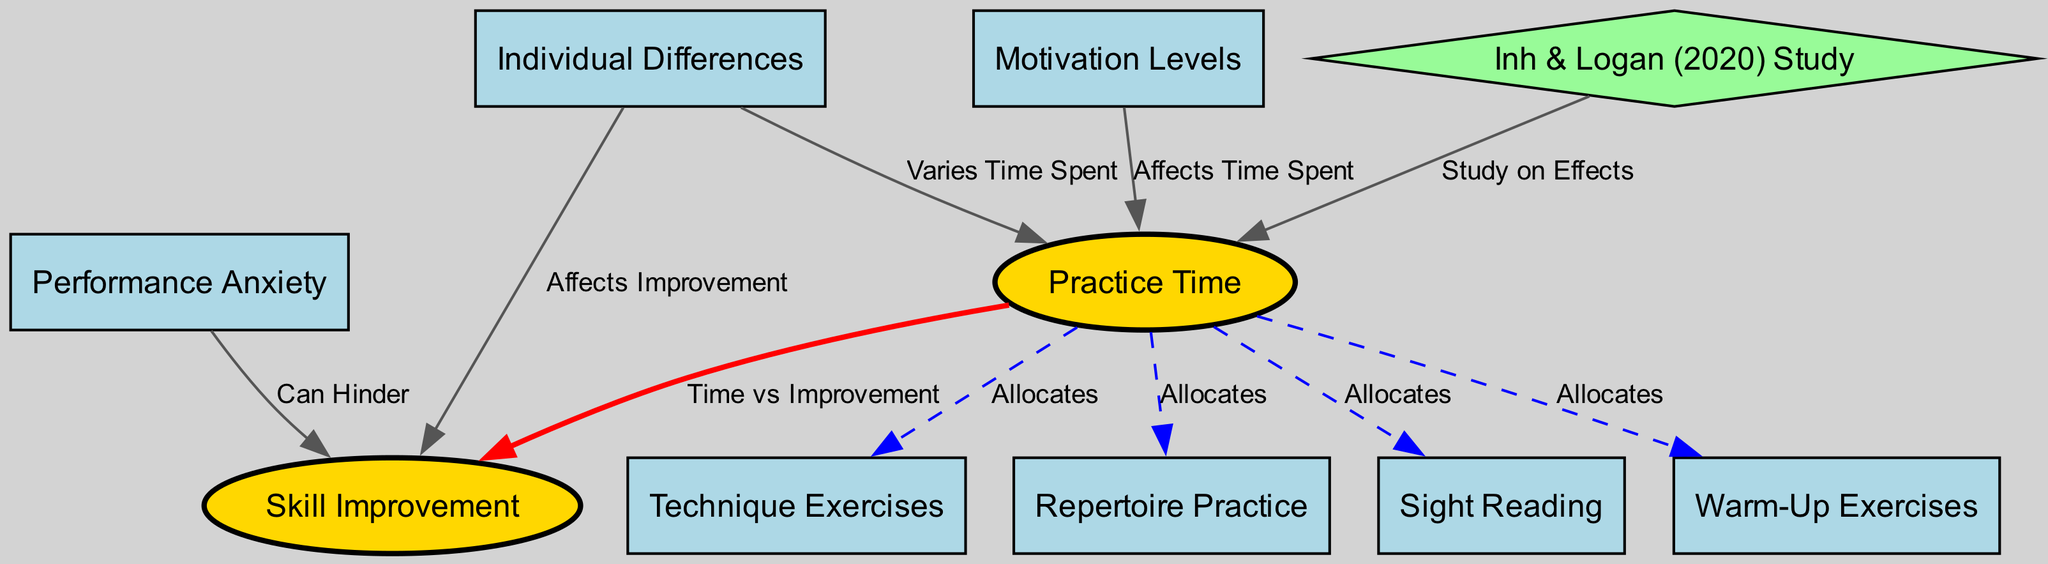What are the two main nodes in this diagram? The two main nodes are identified as "Practice Time" and "Skill Improvement," which are depicted in ellipses. These nodes represent the core concepts being analyzed in the practice routines of classical guitarists.
Answer: Practice Time, Skill Improvement How many edges are connected to the "Practice Time" node? By inspecting the diagram, we can count the edges that extend from "Practice Time." There are five edges leading to "Warm-Up Exercises," "Technique Exercises," "Repertoire Practice," "Sight Reading," and "Skill Improvement."
Answer: Five What does the edge between "Motivation Levels" and "Practice Time" represent? The edge labeled "Affects Time Spent" illustrates the relationship where motivation levels impact the amount of time spent on practice. This denotes that a higher motivation may lead to increased practice time.
Answer: Affects Time Spent Which node can hinder "Skill Improvement"? The edge labeled "Can Hinder" points from "Performance Anxiety" to "Skill Improvement," indicating that performance anxiety can negatively affect a guitarist's ability to improve their skills.
Answer: Performance Anxiety What type of study is linked to "Practice Time"? The node "Inh & Logan (2020) Study" has an edge that connects to "Practice Time," suggesting that this study examined the effects of practice time on skill development in classical guitarists.
Answer: Inh & Logan (2020) Study How do individual differences relate to "Skill Improvement"? The edge between "Inter-Personal Differences" and "Skill Improvement" labeled "Affects Improvement" shows that variation in individual characteristics influences the degree of skill improvement. This means personal traits can change how effectively a guitarist enhances their skills.
Answer: Affects Improvement What is the relationship between "Practice Time" and "Skill Improvement"? The edge marked "Time vs Improvement" indicates a direct connection where the amount of practice time is linked to the level of skill improvement, suggesting that more practice generally leads to better skills.
Answer: Time vs Improvement What is the shape of the node representing the study on effects? The node for "Inh & Logan (2020) Study" is depicted as a diamond, differentiating it from the other nodes that are mostly rectangles and ellipses, which indicates it represents a specific research finding rather than a routine aspect of practice.
Answer: Diamond 